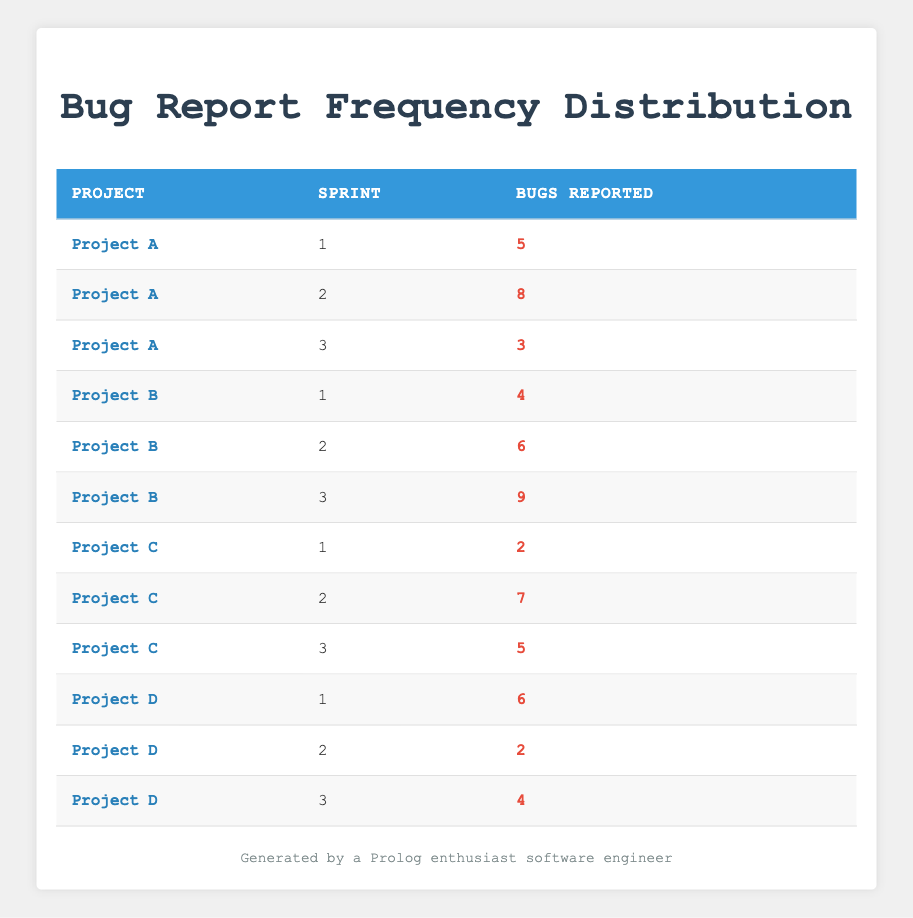What is the total number of bugs reported in Project A across all sprints? To find the total number of bugs reported in Project A, we add the bugs reported in each sprint: 5 (sprint 1) + 8 (sprint 2) + 3 (sprint 3) = 16.
Answer: 16 What was the highest number of bugs reported in a single sprint across all projects? By examining the table, we see the bugs reported in each sprint: Project A (8), Project B (9), Project C (7), Project D (6). The highest value is 9 in Project B during sprint 3.
Answer: 9 Was there a sprint in Project D where no bugs were reported? Looking at the bugs reported for Project D, we have 6 (sprint 1), 2 (sprint 2), and 4 (sprint 3). There are no entries with zero bugs reported.
Answer: No Calculate the average number of bugs reported per sprint for all projects combined. First, we sum all the bugs reported: (5 + 8 + 3 + 4 + 6 + 9 + 2 + 7 + 5 + 6 + 2 + 4) = 57. There are 12 sprints total, so the average is 57 / 12 = 4.75.
Answer: 4.75 Which project had the least number of bugs reported in its first sprint, and how many were reported? In the first sprints, the bugs reported were: Project A (5), Project B (4), Project C (2), Project D (6). Project C had the least with 2 bugs reported.
Answer: Project C, 2 How many more bugs were reported in the second sprint of Project A compared to Project D? In Project A (sprint 2), 8 bugs were reported, and in Project D (sprint 2), 2 bugs were reported. The difference is 8 - 2 = 6.
Answer: 6 What is the median number of bugs reported in sprint 3 across all projects? Sorting the bugs reported in sprint 3: Project A (3), Project B (9), Project C (5), and Project D (4) gives us the sorted list: 3, 4, 5, 9. The median (average of the two middle values) is (4 + 5) / 2 = 4.5.
Answer: 4.5 Did any project report the same number of bugs in all its sprints? Checking each project, Project A has reported 5, 8, and 3; Project B has reported 4, 6, and 9; Project C has reported 2, 7, and 5; Project D has reported 6, 2, and 4. None reported the same number in all sprints.
Answer: No 